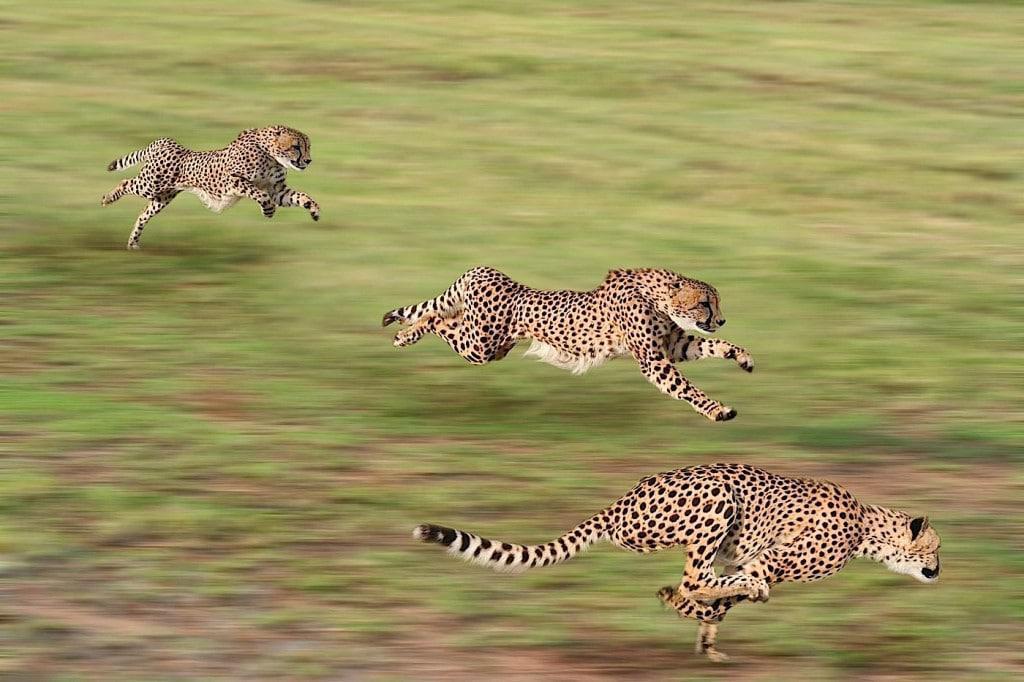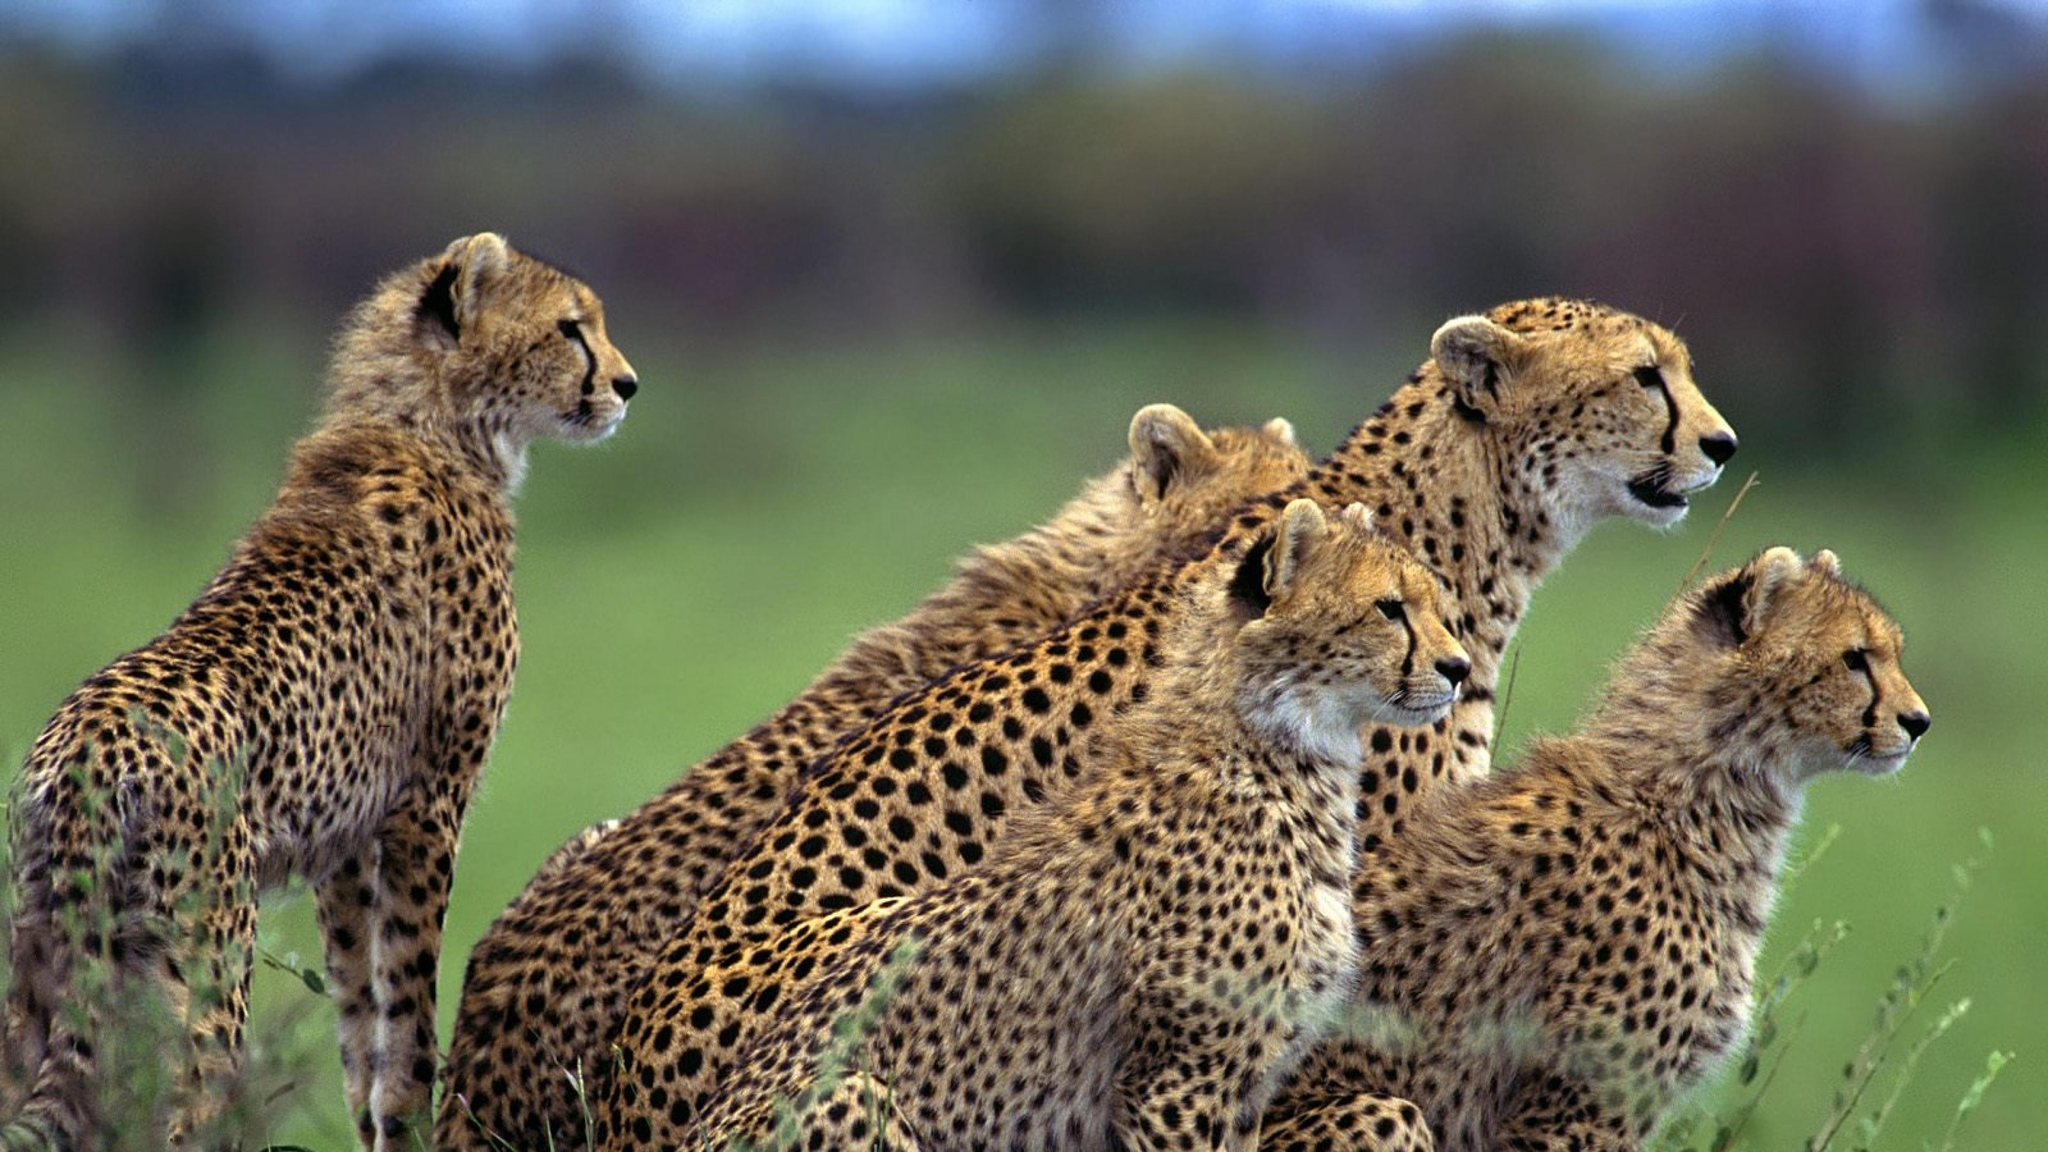The first image is the image on the left, the second image is the image on the right. Considering the images on both sides, is "Multiple spotted wild cats are in action poses in one of the images." valid? Answer yes or no. Yes. The first image is the image on the left, the second image is the image on the right. Given the left and right images, does the statement "The leopards in one of the images are moving quickly across the field." hold true? Answer yes or no. Yes. 